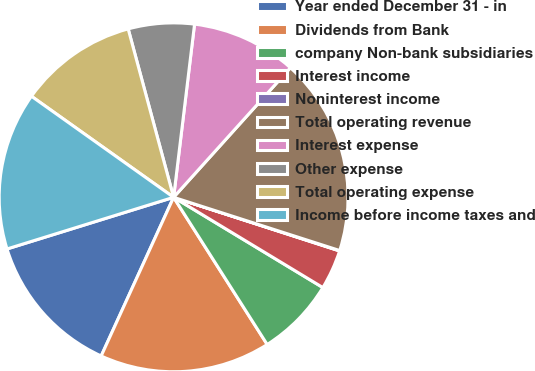Convert chart to OTSL. <chart><loc_0><loc_0><loc_500><loc_500><pie_chart><fcel>Year ended December 31 - in<fcel>Dividends from Bank<fcel>company Non-bank subsidiaries<fcel>Interest income<fcel>Noninterest income<fcel>Total operating revenue<fcel>Interest expense<fcel>Other expense<fcel>Total operating expense<fcel>Income before income taxes and<nl><fcel>13.4%<fcel>15.83%<fcel>7.33%<fcel>3.68%<fcel>0.04%<fcel>18.26%<fcel>9.76%<fcel>6.11%<fcel>10.97%<fcel>14.62%<nl></chart> 